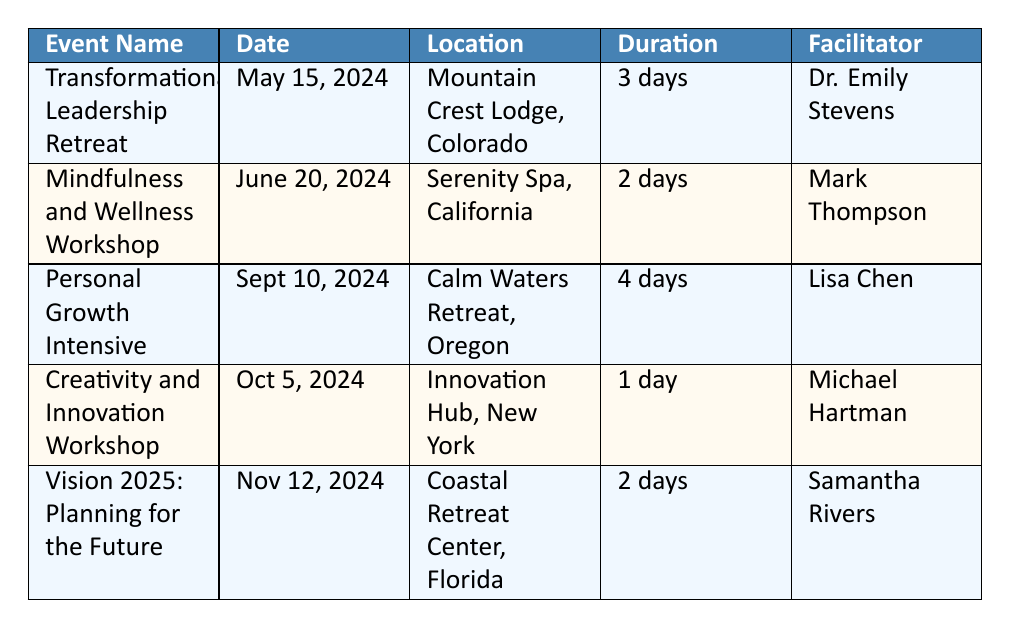What is the date of the Mindfulness and Wellness Workshop? The date is listed directly in the table under the "Date" column for that specific event. The Mindfulness and Wellness Workshop is scheduled for June 20, 2024.
Answer: June 20, 2024 How many days does the Personal Growth Intensive last? The duration of the Personal Growth Intensive is found in the "Duration" column where it states "4 days."
Answer: 4 days Who is the facilitator for the Transformational Leadership Retreat? The facilitator's name for the Transformational Leadership Retreat is indicated in the "Facilitator" column. It states the facilitator is Dr. Emily Stevens.
Answer: Dr. Emily Stevens Is the registration fee for the Creativity and Innovation Workshop higher than $300? The registration fee for the Creativity and Innovation Workshop is listed as $250, which is lower than $300. Therefore, the statement is false.
Answer: No What is the average registration fee for all five events? To find the average, sum the registration fees: 500 + 350 + 600 + 250 + 450 = 2150. Then divide by the number of events (5): 2150/5 = 430.
Answer: 430 Which event is targeted at entrepreneurs and business leaders? By reviewing the "Target Audience" column, the event specifically targeted at entrepreneurs and business leaders is identified as "Vision 2025: Planning for the Future."
Answer: Vision 2025: Planning for the Future How many days in total are the workshops and retreats combined? Calculate the total duration by adding the duration of each event: 3 (Transformational Leadership) + 2 (Mindfulness and Wellness) + 4 (Personal Growth Intensive) + 1 (Creativity and Innovation) + 2 (Vision 2025) = 12 days.
Answer: 12 days Does Lisa Chen facilitate any workshop in 2024? Checking the "Facilitator" column, Lisa Chen is the facilitator for the "Personal Growth Intensive," confirming that she does facilitate a workshop in 2024.
Answer: Yes How many topics are covered in the Mindfulness and Wellness Workshop? The number of topics covered is listed specifically under the "Topics Covered" for that event. There are three topics mentioned: Meditation Techniques, Stress Management, and Work-Life Balance Strategies.
Answer: 3 